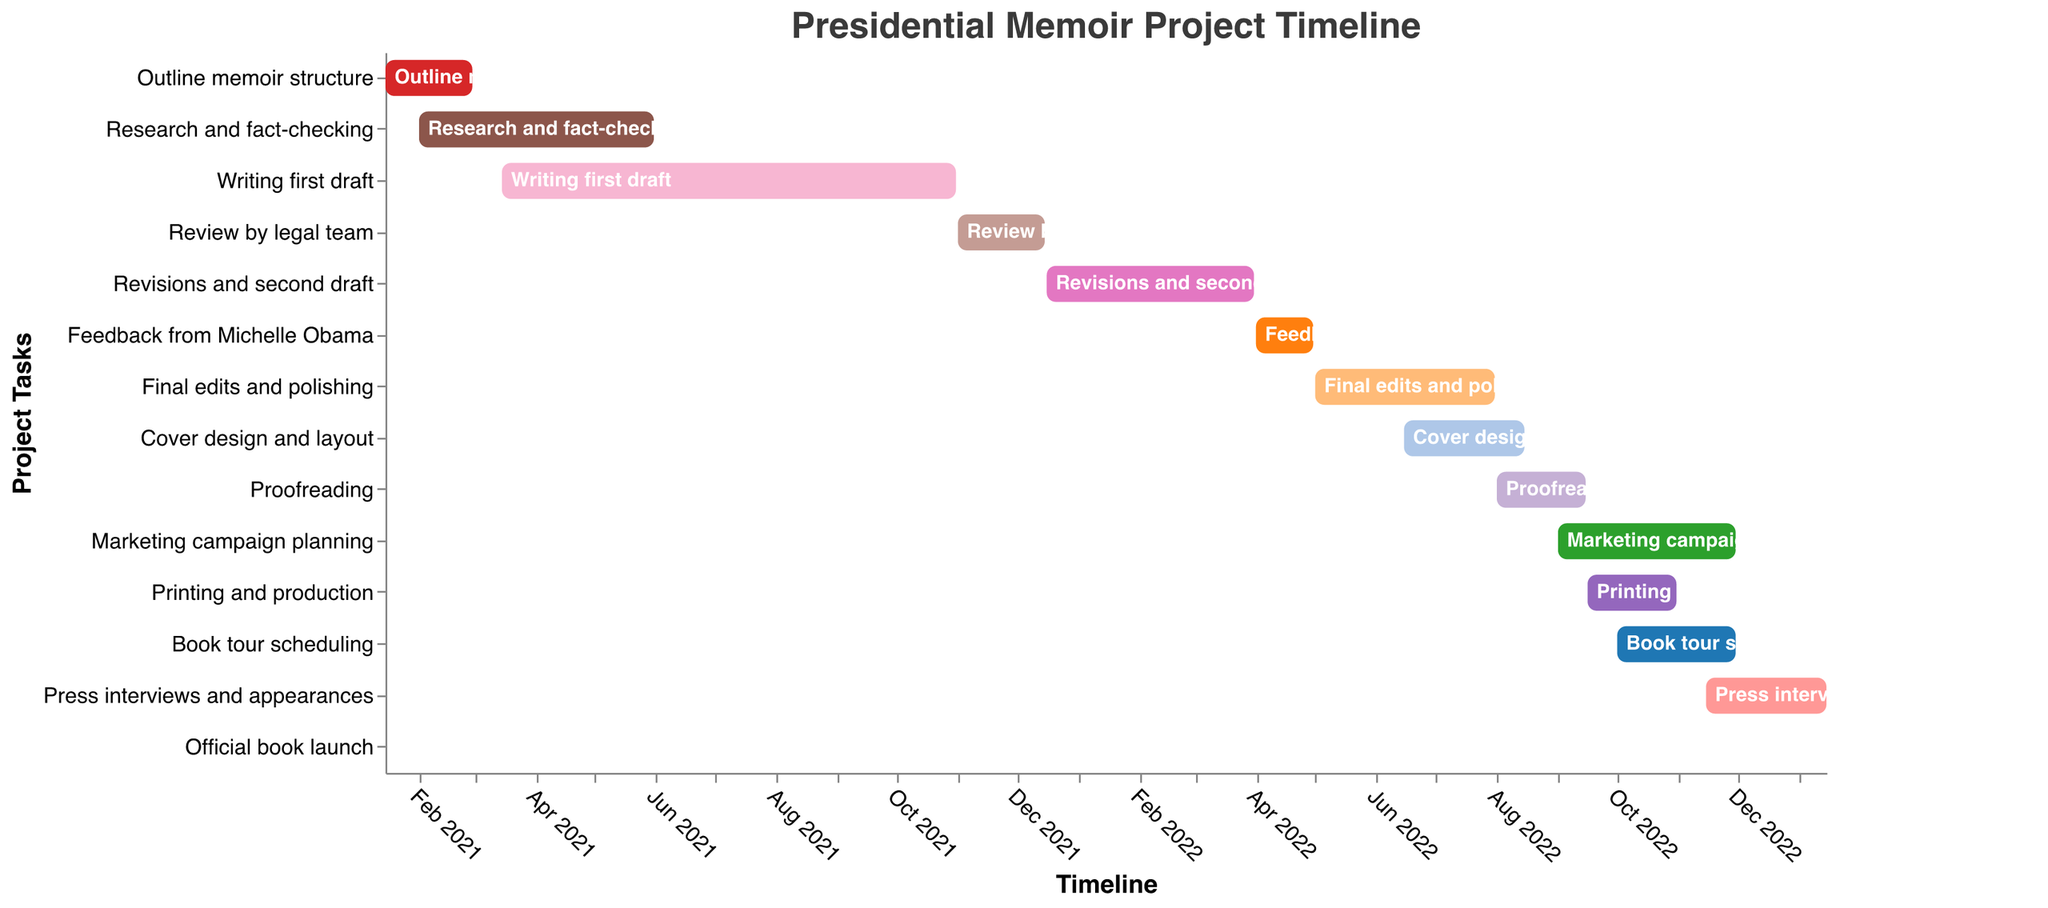What's the title of the Gantt chart? The title is typically located at the top of the chart, providing an overview of the information being visualized. In this case, it can be read as "Presidential Memoir Project Timeline".
Answer: Presidential Memoir Project Timeline How many tasks are depicted in the Gantt chart? Count the number of distinct tasks listed on the y-axis of the chart. There are 14 tasks in total.
Answer: 14 Which task has the longest duration? The "Writing first draft" task spans the longest bar horizontally, indicating it has the longest duration, which is 230 days.
Answer: Writing first draft When does the "Outline memoir structure" task start and end? Look at the bar corresponding to "Outline memoir structure". The task starts on January 15, 2021, and ends on February 28, 2021.
Answer: January 15, 2021 to February 28, 2021 What is the difference in the number of days between the start of "Research and fact-checking" and the end of "Review by legal team"? "Research and fact-checking" starts on February 1, 2021. "Review by legal team" ends on December 15, 2021. Calculate the difference between these two dates. The difference is 317 days.
Answer: 317 days Which tasks overlap in the month of October 2022? Identify the tasks whose bars span over October 2022. "Proofreading", "Printing and production", "Marketing campaign planning", and "Book tour scheduling" all overlap in October 2022.
Answer: Proofreading, Printing and production, Marketing campaign planning, Book tour scheduling How many tasks are scheduled to start in 2022? Look at the x-axis for tasks that have their start dates in the year 2022. There are 8 tasks that start in 2022.
Answer: 8 Which task has the shortest duration? "Official book launch" has the shortest bar, indicating a duration of only 1 day.
Answer: Official book launch What is the total duration of "Final edits and polishing"? The duration is given directly in the data. "Final edits and polishing" is scheduled for 92 days.
Answer: 92 days When does the "Marketing campaign planning" start? Locate the bar for "Marketing campaign planning". It starts on September 1, 2022.
Answer: September 1, 2022 